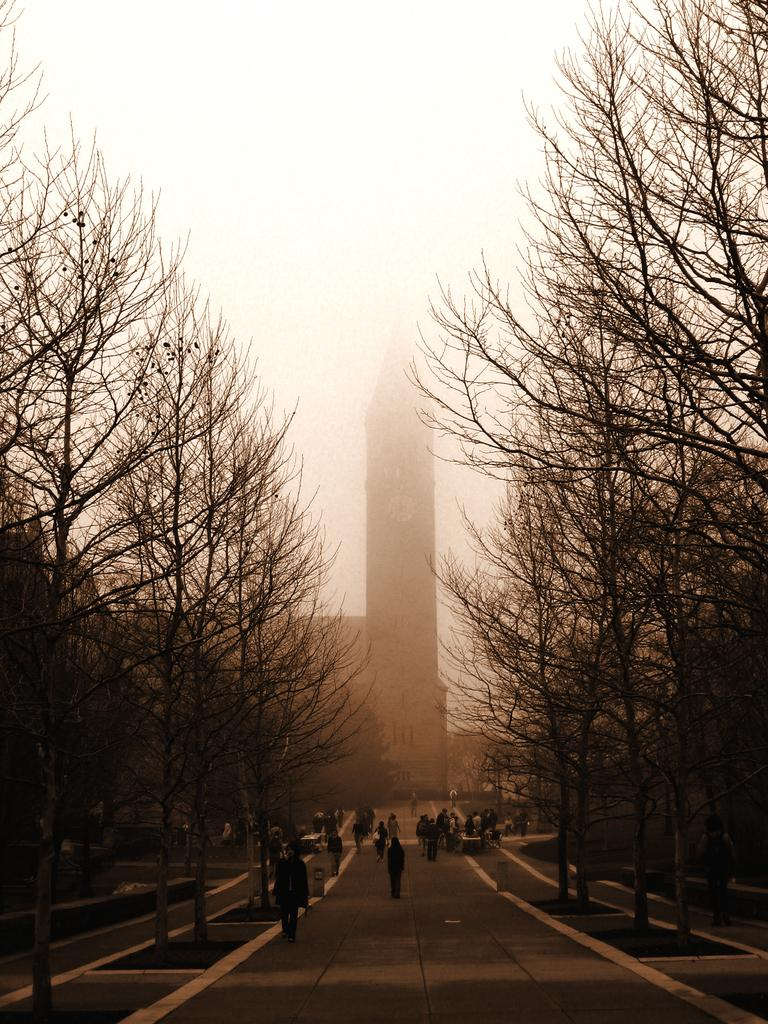What type of natural elements can be seen in the image? There are trees in the image. What are the people in the image doing? There is a group of people on the road in the image. Can you describe any man-made structures in the image? There is a building in the background of the image. What can be seen in the sky in the image? The sky is visible in the background of the image. What type of battle is taking place in the image? There is no battle present in the image; it features trees, a group of people on the road, a building in the background, and the sky. Can you see any ants in the image? There are no ants present in the image. 